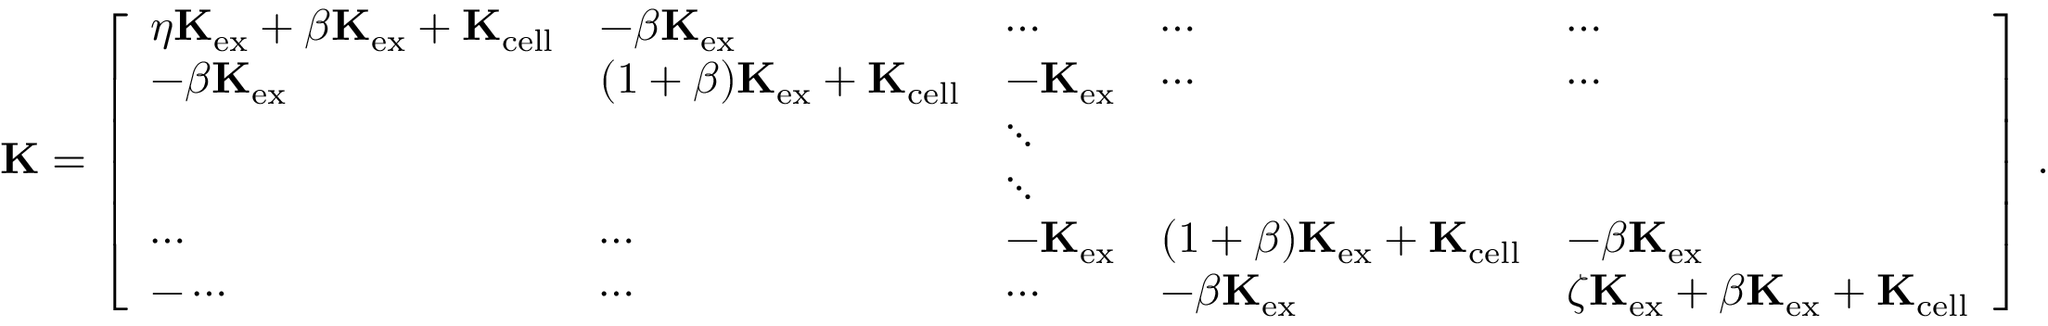<formula> <loc_0><loc_0><loc_500><loc_500>K = \left [ \begin{array} { l l l l l } { \eta K _ { e x } + \beta K _ { e x } + K _ { c e l l } } & { - \beta K _ { e x } } & { \cdots } & { \cdots } & { \cdots } \\ { - \beta K _ { e x } } & { ( 1 + \beta ) K _ { e x } + K _ { c e l l } } & { - K _ { e x } } & { \cdots } & { \cdots } \\ & & { \ddots } & & \\ & & { \ddots } & & \\ { \cdots } & { \cdots } & { - K _ { e x } } & { ( 1 + \beta ) K _ { e x } + K _ { c e l l } } & { - \beta K _ { e x } } \\ { - \cdots } & { \cdots } & { \cdots } & { - \beta K _ { e x } } & { \zeta K _ { e x } + \beta K _ { e x } + K _ { c e l l } } \end{array} \right ] \, .</formula> 